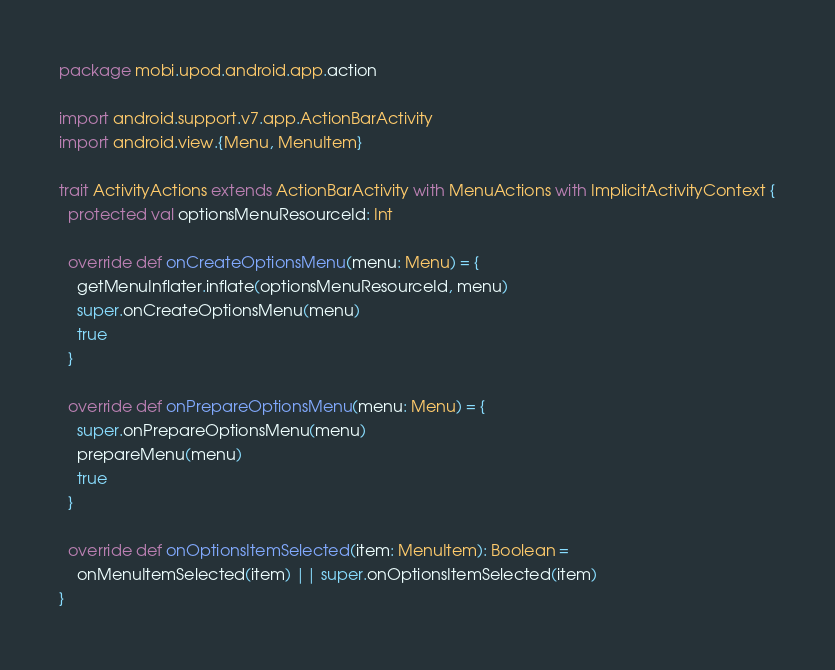<code> <loc_0><loc_0><loc_500><loc_500><_Scala_>package mobi.upod.android.app.action

import android.support.v7.app.ActionBarActivity
import android.view.{Menu, MenuItem}

trait ActivityActions extends ActionBarActivity with MenuActions with ImplicitActivityContext {
  protected val optionsMenuResourceId: Int

  override def onCreateOptionsMenu(menu: Menu) = {
    getMenuInflater.inflate(optionsMenuResourceId, menu)
    super.onCreateOptionsMenu(menu)
    true
  }

  override def onPrepareOptionsMenu(menu: Menu) = {
    super.onPrepareOptionsMenu(menu)
    prepareMenu(menu)
    true
  }

  override def onOptionsItemSelected(item: MenuItem): Boolean =
    onMenuItemSelected(item) || super.onOptionsItemSelected(item)
}
</code> 